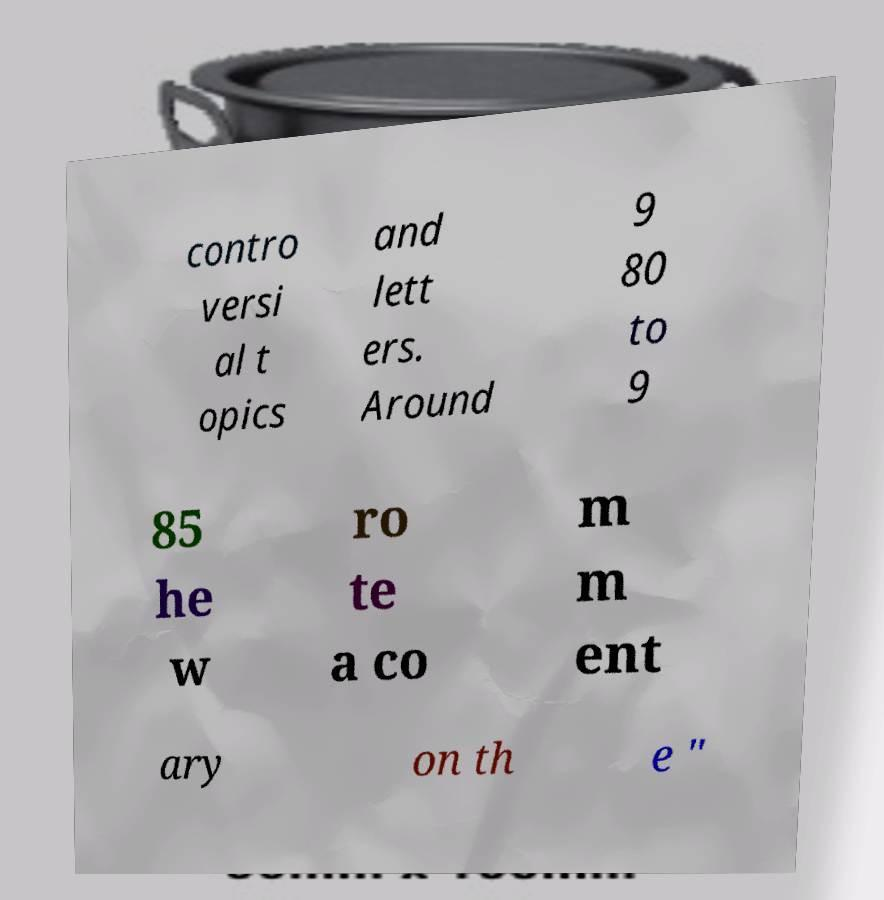For documentation purposes, I need the text within this image transcribed. Could you provide that? contro versi al t opics and lett ers. Around 9 80 to 9 85 he w ro te a co m m ent ary on th e " 